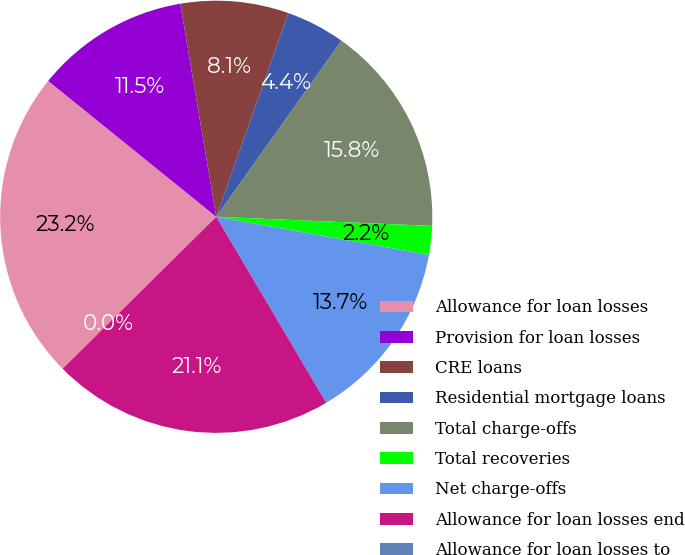<chart> <loc_0><loc_0><loc_500><loc_500><pie_chart><fcel>Allowance for loan losses<fcel>Provision for loan losses<fcel>CRE loans<fcel>Residential mortgage loans<fcel>Total charge-offs<fcel>Total recoveries<fcel>Net charge-offs<fcel>Allowance for loan losses end<fcel>Allowance for loan losses to<nl><fcel>23.23%<fcel>11.52%<fcel>8.08%<fcel>4.42%<fcel>15.83%<fcel>2.15%<fcel>13.68%<fcel>21.08%<fcel>0.0%<nl></chart> 